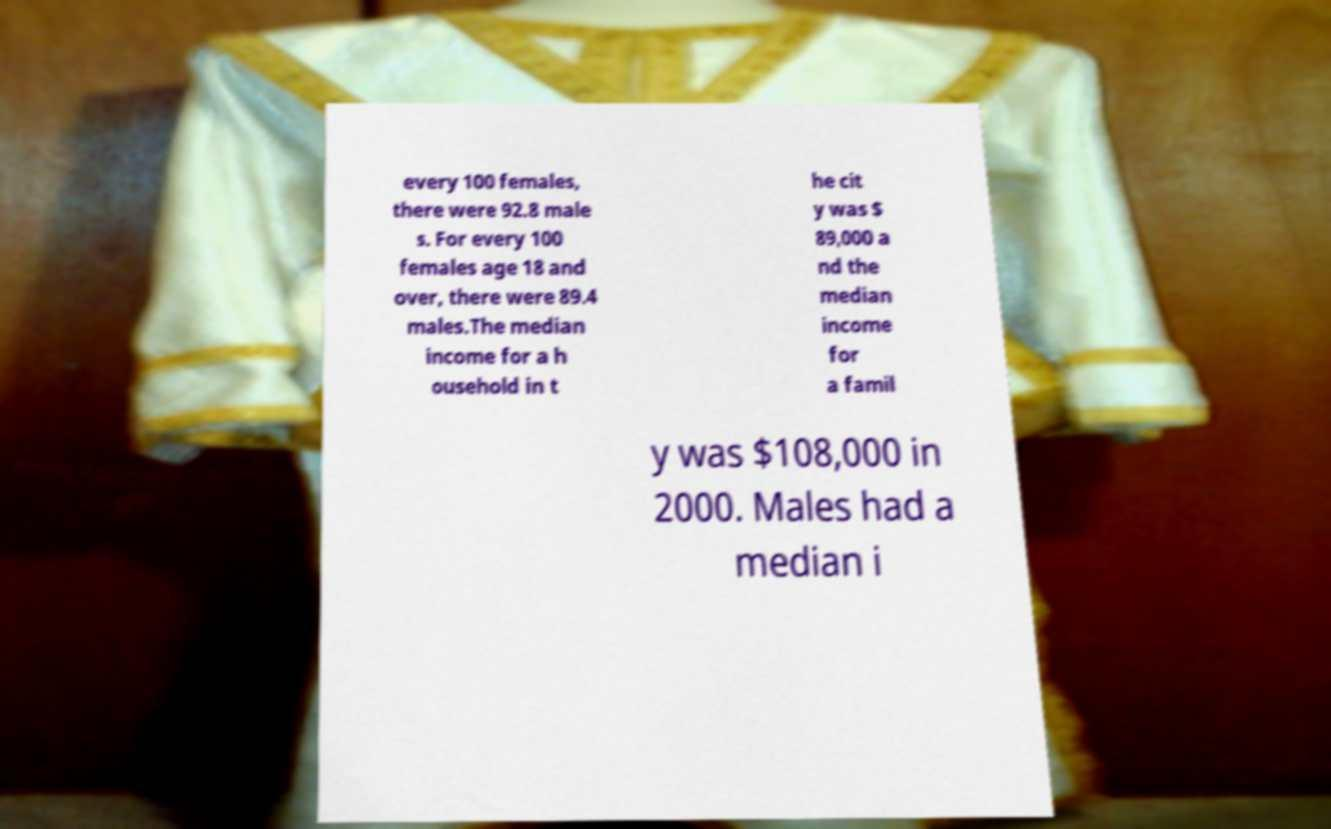Could you assist in decoding the text presented in this image and type it out clearly? every 100 females, there were 92.8 male s. For every 100 females age 18 and over, there were 89.4 males.The median income for a h ousehold in t he cit y was $ 89,000 a nd the median income for a famil y was $108,000 in 2000. Males had a median i 